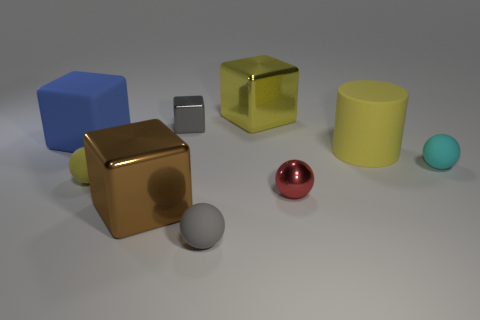Are there any other things that have the same color as the large rubber cylinder?
Give a very brief answer. Yes. Are the yellow thing that is behind the tiny gray block and the gray cube made of the same material?
Your answer should be very brief. Yes. Is the number of small yellow rubber objects that are to the right of the red sphere the same as the number of small rubber spheres to the left of the small cyan matte sphere?
Provide a succinct answer. No. There is a yellow rubber object that is right of the big block that is behind the big blue block; what size is it?
Make the answer very short. Large. There is a ball that is behind the tiny red shiny thing and right of the gray sphere; what is it made of?
Your answer should be very brief. Rubber. How many other things are the same size as the cyan ball?
Offer a terse response. 4. The tiny cube is what color?
Provide a succinct answer. Gray. Do the big rubber object on the right side of the yellow rubber ball and the large shiny cube behind the large yellow rubber thing have the same color?
Offer a very short reply. Yes. The gray metal cube is what size?
Your answer should be very brief. Small. There is a yellow rubber thing to the right of the small gray sphere; what size is it?
Offer a very short reply. Large. 